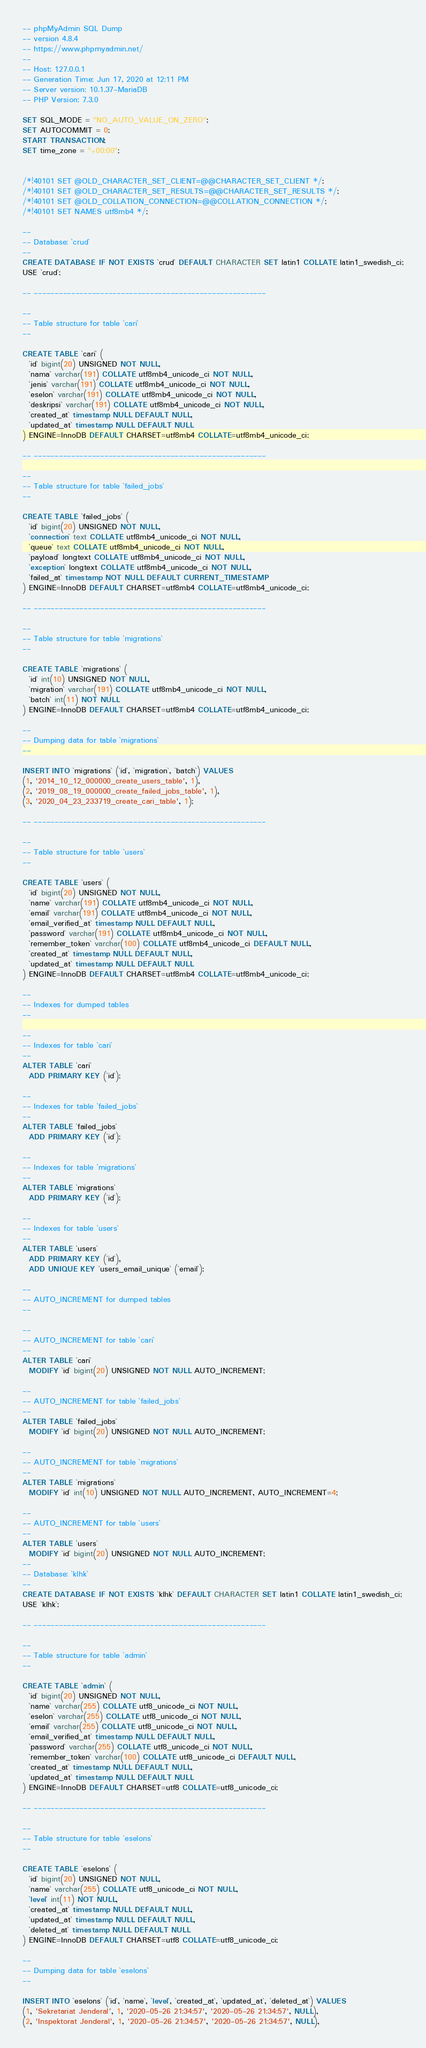<code> <loc_0><loc_0><loc_500><loc_500><_SQL_>-- phpMyAdmin SQL Dump
-- version 4.8.4
-- https://www.phpmyadmin.net/
--
-- Host: 127.0.0.1
-- Generation Time: Jun 17, 2020 at 12:11 PM
-- Server version: 10.1.37-MariaDB
-- PHP Version: 7.3.0

SET SQL_MODE = "NO_AUTO_VALUE_ON_ZERO";
SET AUTOCOMMIT = 0;
START TRANSACTION;
SET time_zone = "+00:00";


/*!40101 SET @OLD_CHARACTER_SET_CLIENT=@@CHARACTER_SET_CLIENT */;
/*!40101 SET @OLD_CHARACTER_SET_RESULTS=@@CHARACTER_SET_RESULTS */;
/*!40101 SET @OLD_COLLATION_CONNECTION=@@COLLATION_CONNECTION */;
/*!40101 SET NAMES utf8mb4 */;

--
-- Database: `crud`
--
CREATE DATABASE IF NOT EXISTS `crud` DEFAULT CHARACTER SET latin1 COLLATE latin1_swedish_ci;
USE `crud`;

-- --------------------------------------------------------

--
-- Table structure for table `cari`
--

CREATE TABLE `cari` (
  `id` bigint(20) UNSIGNED NOT NULL,
  `nama` varchar(191) COLLATE utf8mb4_unicode_ci NOT NULL,
  `jenis` varchar(191) COLLATE utf8mb4_unicode_ci NOT NULL,
  `eselon` varchar(191) COLLATE utf8mb4_unicode_ci NOT NULL,
  `deskripsi` varchar(191) COLLATE utf8mb4_unicode_ci NOT NULL,
  `created_at` timestamp NULL DEFAULT NULL,
  `updated_at` timestamp NULL DEFAULT NULL
) ENGINE=InnoDB DEFAULT CHARSET=utf8mb4 COLLATE=utf8mb4_unicode_ci;

-- --------------------------------------------------------

--
-- Table structure for table `failed_jobs`
--

CREATE TABLE `failed_jobs` (
  `id` bigint(20) UNSIGNED NOT NULL,
  `connection` text COLLATE utf8mb4_unicode_ci NOT NULL,
  `queue` text COLLATE utf8mb4_unicode_ci NOT NULL,
  `payload` longtext COLLATE utf8mb4_unicode_ci NOT NULL,
  `exception` longtext COLLATE utf8mb4_unicode_ci NOT NULL,
  `failed_at` timestamp NOT NULL DEFAULT CURRENT_TIMESTAMP
) ENGINE=InnoDB DEFAULT CHARSET=utf8mb4 COLLATE=utf8mb4_unicode_ci;

-- --------------------------------------------------------

--
-- Table structure for table `migrations`
--

CREATE TABLE `migrations` (
  `id` int(10) UNSIGNED NOT NULL,
  `migration` varchar(191) COLLATE utf8mb4_unicode_ci NOT NULL,
  `batch` int(11) NOT NULL
) ENGINE=InnoDB DEFAULT CHARSET=utf8mb4 COLLATE=utf8mb4_unicode_ci;

--
-- Dumping data for table `migrations`
--

INSERT INTO `migrations` (`id`, `migration`, `batch`) VALUES
(1, '2014_10_12_000000_create_users_table', 1),
(2, '2019_08_19_000000_create_failed_jobs_table', 1),
(3, '2020_04_23_233719_create_cari_table', 1);

-- --------------------------------------------------------

--
-- Table structure for table `users`
--

CREATE TABLE `users` (
  `id` bigint(20) UNSIGNED NOT NULL,
  `name` varchar(191) COLLATE utf8mb4_unicode_ci NOT NULL,
  `email` varchar(191) COLLATE utf8mb4_unicode_ci NOT NULL,
  `email_verified_at` timestamp NULL DEFAULT NULL,
  `password` varchar(191) COLLATE utf8mb4_unicode_ci NOT NULL,
  `remember_token` varchar(100) COLLATE utf8mb4_unicode_ci DEFAULT NULL,
  `created_at` timestamp NULL DEFAULT NULL,
  `updated_at` timestamp NULL DEFAULT NULL
) ENGINE=InnoDB DEFAULT CHARSET=utf8mb4 COLLATE=utf8mb4_unicode_ci;

--
-- Indexes for dumped tables
--

--
-- Indexes for table `cari`
--
ALTER TABLE `cari`
  ADD PRIMARY KEY (`id`);

--
-- Indexes for table `failed_jobs`
--
ALTER TABLE `failed_jobs`
  ADD PRIMARY KEY (`id`);

--
-- Indexes for table `migrations`
--
ALTER TABLE `migrations`
  ADD PRIMARY KEY (`id`);

--
-- Indexes for table `users`
--
ALTER TABLE `users`
  ADD PRIMARY KEY (`id`),
  ADD UNIQUE KEY `users_email_unique` (`email`);

--
-- AUTO_INCREMENT for dumped tables
--

--
-- AUTO_INCREMENT for table `cari`
--
ALTER TABLE `cari`
  MODIFY `id` bigint(20) UNSIGNED NOT NULL AUTO_INCREMENT;

--
-- AUTO_INCREMENT for table `failed_jobs`
--
ALTER TABLE `failed_jobs`
  MODIFY `id` bigint(20) UNSIGNED NOT NULL AUTO_INCREMENT;

--
-- AUTO_INCREMENT for table `migrations`
--
ALTER TABLE `migrations`
  MODIFY `id` int(10) UNSIGNED NOT NULL AUTO_INCREMENT, AUTO_INCREMENT=4;

--
-- AUTO_INCREMENT for table `users`
--
ALTER TABLE `users`
  MODIFY `id` bigint(20) UNSIGNED NOT NULL AUTO_INCREMENT;
--
-- Database: `klhk`
--
CREATE DATABASE IF NOT EXISTS `klhk` DEFAULT CHARACTER SET latin1 COLLATE latin1_swedish_ci;
USE `klhk`;

-- --------------------------------------------------------

--
-- Table structure for table `admin`
--

CREATE TABLE `admin` (
  `id` bigint(20) UNSIGNED NOT NULL,
  `name` varchar(255) COLLATE utf8_unicode_ci NOT NULL,
  `eselon` varchar(255) COLLATE utf8_unicode_ci NOT NULL,
  `email` varchar(255) COLLATE utf8_unicode_ci NOT NULL,
  `email_verified_at` timestamp NULL DEFAULT NULL,
  `password` varchar(255) COLLATE utf8_unicode_ci NOT NULL,
  `remember_token` varchar(100) COLLATE utf8_unicode_ci DEFAULT NULL,
  `created_at` timestamp NULL DEFAULT NULL,
  `updated_at` timestamp NULL DEFAULT NULL
) ENGINE=InnoDB DEFAULT CHARSET=utf8 COLLATE=utf8_unicode_ci;

-- --------------------------------------------------------

--
-- Table structure for table `eselons`
--

CREATE TABLE `eselons` (
  `id` bigint(20) UNSIGNED NOT NULL,
  `name` varchar(255) COLLATE utf8_unicode_ci NOT NULL,
  `level` int(11) NOT NULL,
  `created_at` timestamp NULL DEFAULT NULL,
  `updated_at` timestamp NULL DEFAULT NULL,
  `deleted_at` timestamp NULL DEFAULT NULL
) ENGINE=InnoDB DEFAULT CHARSET=utf8 COLLATE=utf8_unicode_ci;

--
-- Dumping data for table `eselons`
--

INSERT INTO `eselons` (`id`, `name`, `level`, `created_at`, `updated_at`, `deleted_at`) VALUES
(1, 'Sekretariat Jenderal', 1, '2020-05-26 21:34:57', '2020-05-26 21:34:57', NULL),
(2, 'Inspektorat Jenderal', 1, '2020-05-26 21:34:57', '2020-05-26 21:34:57', NULL),</code> 